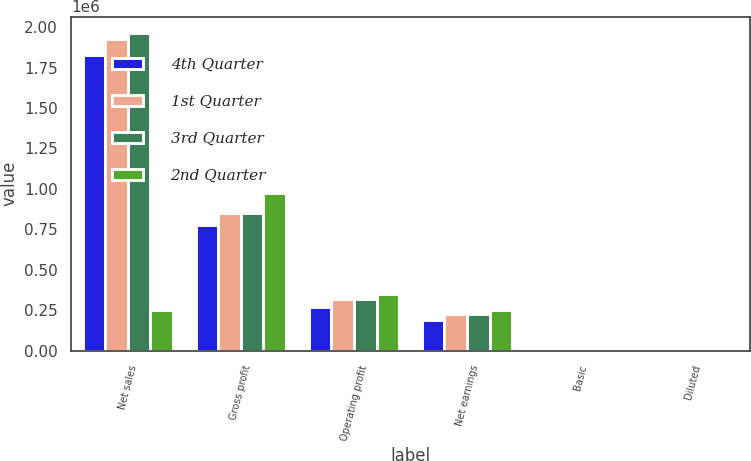Convert chart to OTSL. <chart><loc_0><loc_0><loc_500><loc_500><stacked_bar_chart><ecel><fcel>Net sales<fcel>Gross profit<fcel>Operating profit<fcel>Net earnings<fcel>Basic<fcel>Diluted<nl><fcel>4th Quarter<fcel>1.82595e+06<fcel>775184<fcel>271837<fcel>188256<fcel>0.61<fcel>0.58<nl><fcel>1st Quarter<fcel>1.92863e+06<fcel>849603<fcel>321021<fcel>229020<fcel>0.74<fcel>0.7<nl><fcel>3rd Quarter<fcel>1.96638e+06<fcel>847871<fcel>319682<fcel>228821<fcel>0.74<fcel>0.7<nl><fcel>2nd Quarter<fcel>251703<fcel>972357<fcel>352128<fcel>251703<fcel>0.82<fcel>0.78<nl></chart> 